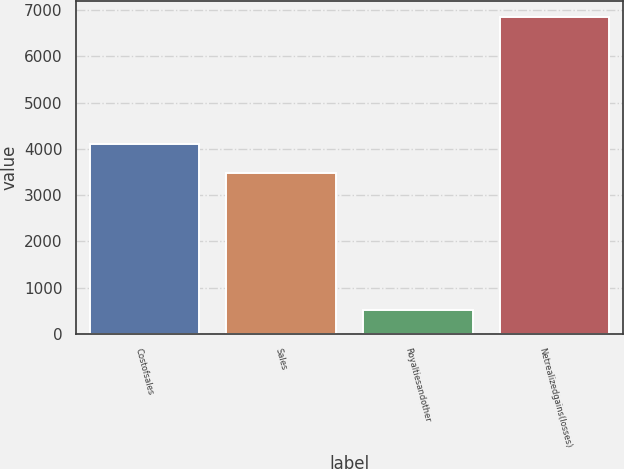Convert chart to OTSL. <chart><loc_0><loc_0><loc_500><loc_500><bar_chart><fcel>Costofsales<fcel>Sales<fcel>Royaltiesandother<fcel>Netrealizedgains(losses)<nl><fcel>4112.4<fcel>3479<fcel>527<fcel>6861<nl></chart> 